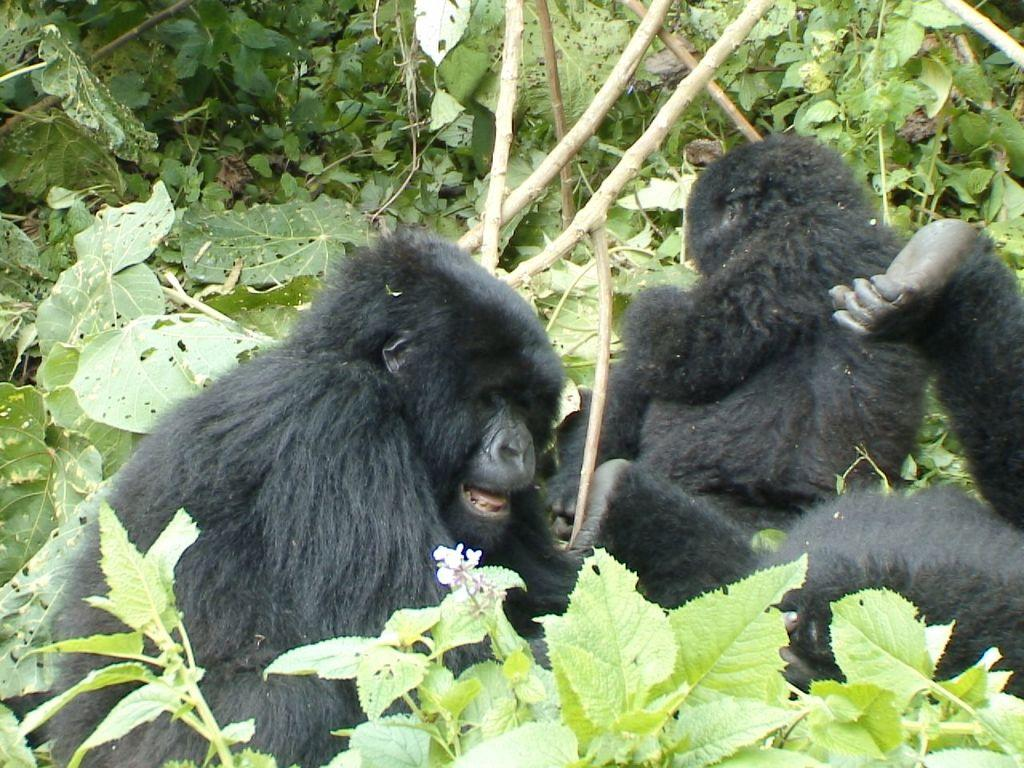What type of animals are in the image? There are black color monkeys in the image. Where are the monkeys located? The monkeys are on the plants. What can be seen on the plants besides the monkeys? There are leaves of the plants visible in the image. What type of bone can be seen in the image? There is no bone present in the image; it features black color monkeys on plants. 